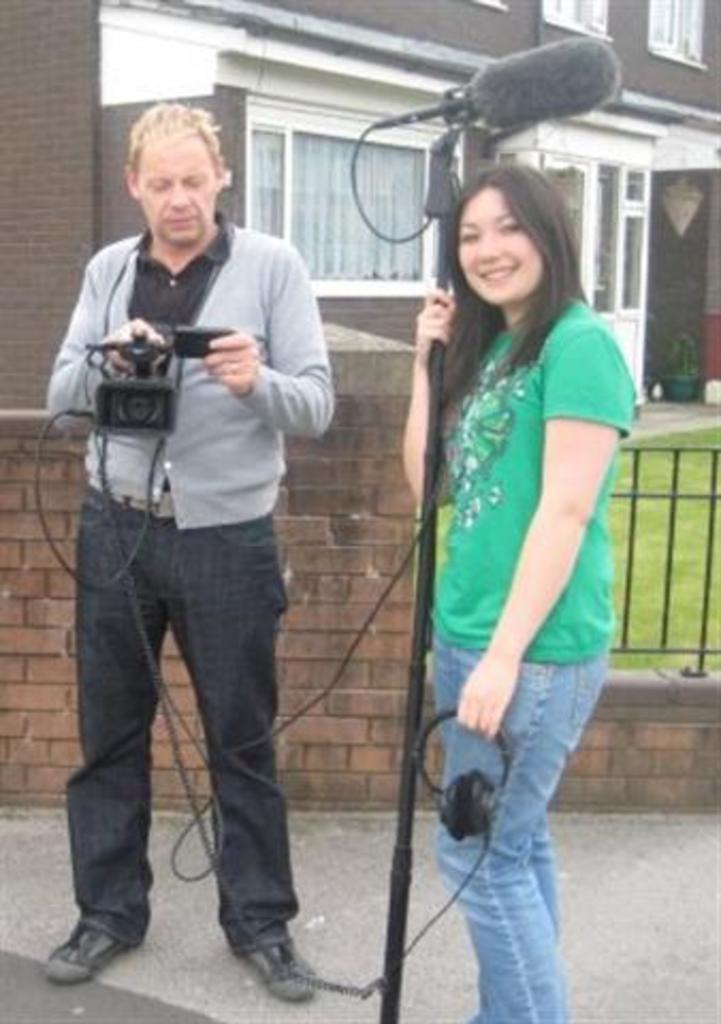How many people are in the image? There are two persons standing in the image. What are the persons holding in the image? The persons are holding objects. What can be seen in the background of the image? There is a building in the background of the image. What type of surface is visible in the image? There is grass in the image. What architectural feature can be seen in the image? There is a wall and a grille in the image. What type of fuel is being used by the lead achiever in the image? There is no mention of fuel, lead, or an achiever in the image. The image features two persons holding objects, a wall, a grille, grass, and a building in the background. 